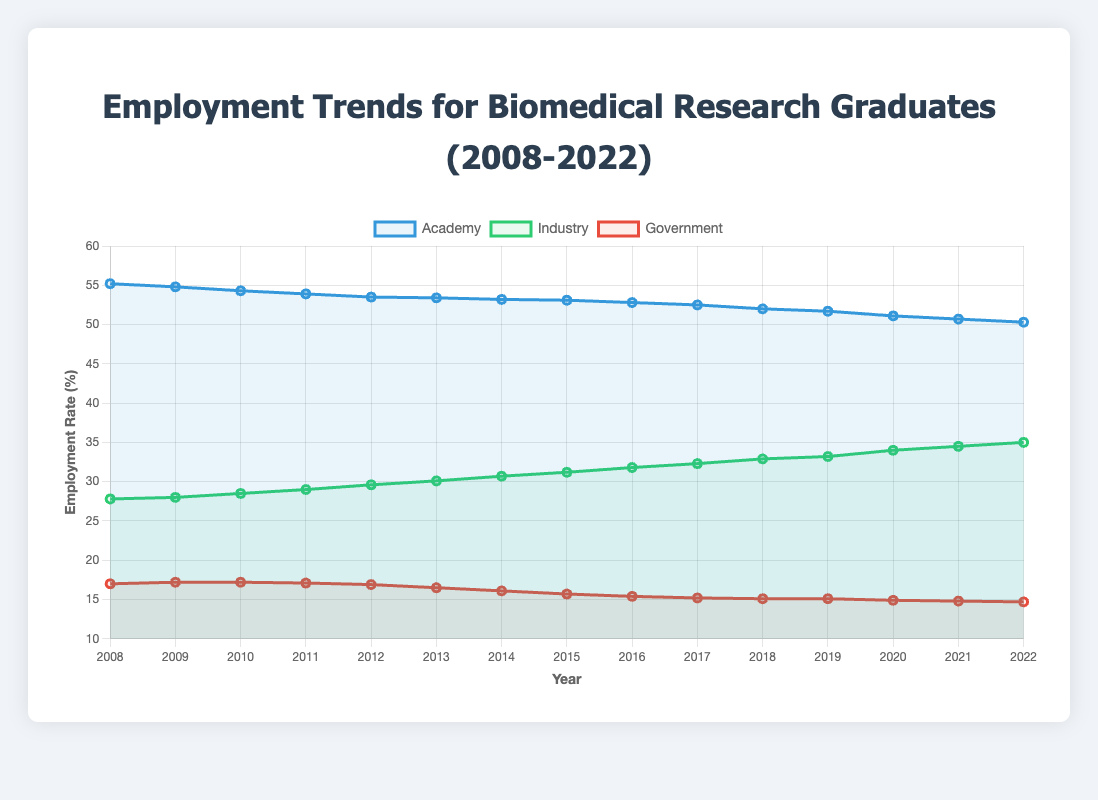What is the employment rate trend in academia from 2008 to 2022? To determine the trend, we observe that the employment rate in academia has consistently decreased from 55.2% in 2008 to 50.3% in 2022.
Answer: Decreasing trend How does the employment rate in industry in 2022 compare to 2008? In 2008, the employment rate in industry was 27.8%, and in 2022, it increased to 35.0%. This shows an increase.
Answer: Increased by 7.2% Which sector saw the smallest change in employment rates from 2008 to 2022? To find the smallest change, calculate the difference for each sector: academia (55.2% - 50.3% = 4.9%), industry (35.0% - 27.8% = 7.2%), government (17.0% - 14.7% = 2.3%). The smallest change is in the government sector.
Answer: Government What was the employment rate in industry in 2015 and how did it change by 2020? The employment rate in industry in 2015 was 31.2%, and by 2020, it increased to 34.0%.
Answer: Increased by 2.8% Compare the employment rates in government and academia in 2020. Which one was higher? In 2020, the employment rate in academia was 51.1%, while in government, it was 14.9%. The rate in academia was higher.
Answer: Academia What was the average employment rate in government from 2010 to 2014? To find the average, add the employment rates for these years (17.2% + 17.1% + 16.9% + 16.5% + 16.1%) = 83.8%, and divide by 5.
Answer: 16.76% In what year did the employment rate in industry first exceed 30%? By examining the data, we see that the employment rate in industry first exceeded 30% in 2013, reaching 30.1%.
Answer: 2013 Are there any years where the employment rates in industry and government were equal? Based on the data, there are no years where the employment rates in industry and government were exactly equal.
Answer: No What is the overall trend in employment rates in the government sector? Observing the data, the employment rate in the government sector has decreased from 17.0% in 2008 to 14.7% in 2022.
Answer: Decreasing trend 